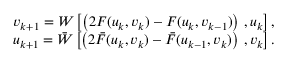<formula> <loc_0><loc_0><loc_500><loc_500>\begin{array} { l } { { v _ { k + 1 } = W \left [ \left ( 2 F ( u _ { k } , v _ { k } ) - F ( u _ { k } , v _ { k - 1 } ) \right ) \, , u _ { k } \right ] , } } \\ { { u _ { k + 1 } = \bar { W } \left [ \left ( 2 \bar { F } ( u _ { k } , v _ { k } ) - \bar { F } ( u _ { k - 1 } , v _ { k } ) \right ) \, , v _ { k } \right ] . } } \end{array}</formula> 